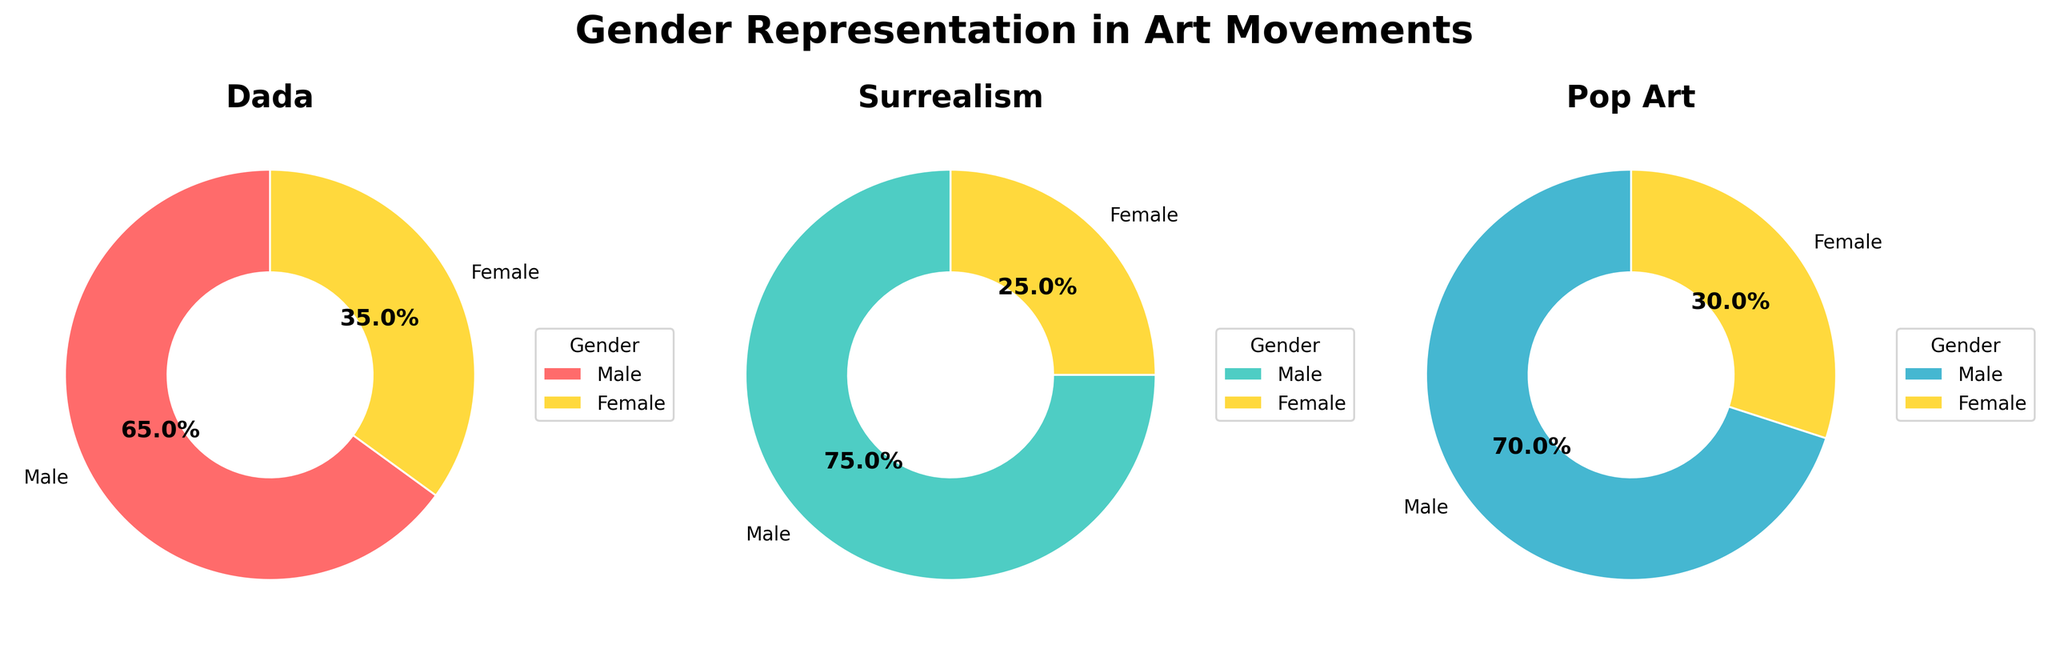Which art movement has the lowest percentage of female artists? The pie charts show that Dada has 35% female artists, Surrealism has 25%, and Pop Art has 30%. Surrealism has the lowest percentage of female artists.
Answer: Surrealism Which art movement has the highest percentage of male artists? The pie charts show that Dada has 65% male artists, Surrealism has 75%, and Pop Art has 70%. Surrealism has the highest percentage of male artists.
Answer: Surrealism What's the average percentage of female artists across all three movements? Sum the percentages of female artists (Dada: 35%, Surrealism: 25%, Pop Art: 30%) and divide by the number of movements. (35 + 25 + 30) / 3 = 30%
Answer: 30% How much larger is the percentage of male artists compared to female artists in the Dada movement? The data shows Dada has 65% male artists and 35% female artists. The difference is 65% - 35% = 30%
Answer: 30% Which two movements have the closest percentages of male artists? Compare the male artist percentages: Dada 65%, Surrealism 75%, Pop Art 70%. The closest values are Dada (65%) and Pop Art (70%). The difference is 70% - 65% = 5%
Answer: Dada and Pop Art What is the combined percentage of female artists in the Surrealism and Pop Art movements? Add the percentages of female artists in Surrealism (25%) and Pop Art (30%). 25% + 30% = 55%
Answer: 55% Which movement has equal male artist representation compared to the combined female artist representation in Dada and Surrealism? Combined female representation in Dada (35%) and Surrealism (25%) is 35% + 25% = 60%. No movement has exactly 60% male artists, so none matches exactly.
Answer: None In which movement is the gender representation gap the smallest? Calculate the gaps: Dada (65% - 35% = 30%), Surrealism (75% - 25% = 50%), and Pop Art (70% - 30% = 40%). The smallest gap is in Dada, with 30%.
Answer: Dada 